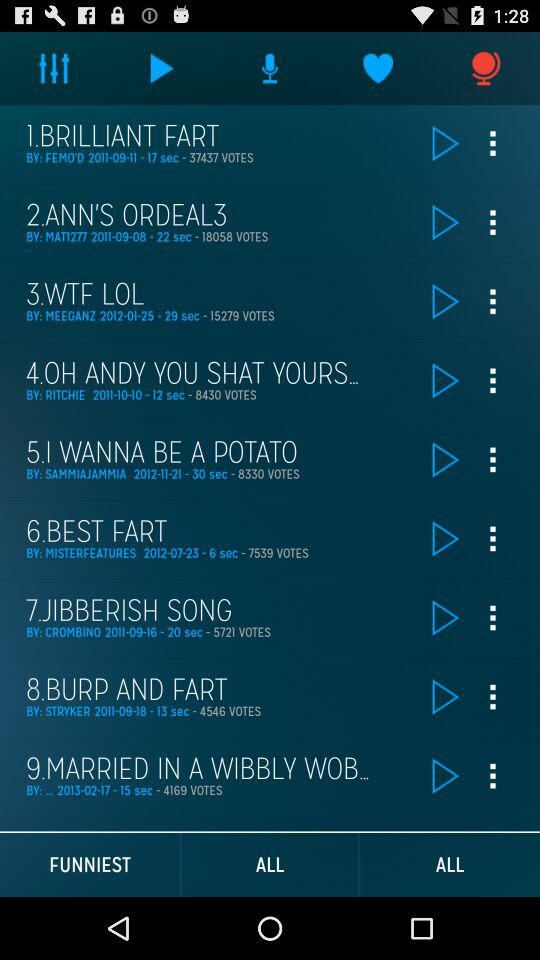How many votes did Best Fart Song get? The Best Fart song got 7539 votes. 